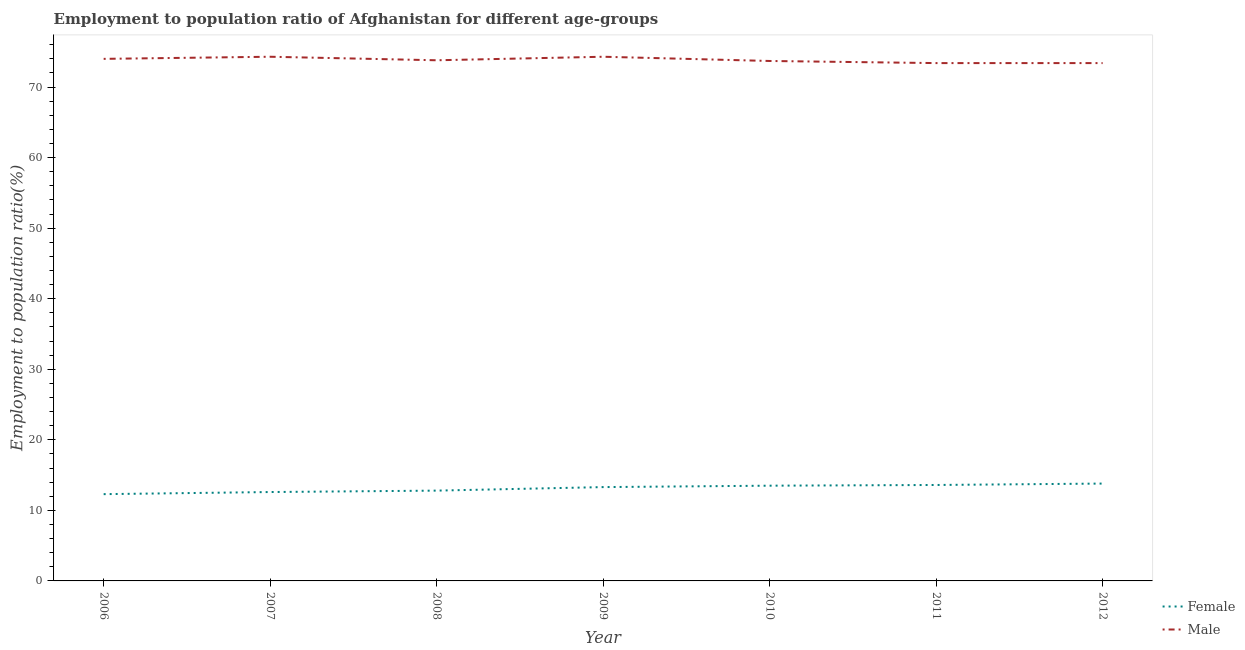How many different coloured lines are there?
Your answer should be very brief. 2. Does the line corresponding to employment to population ratio(female) intersect with the line corresponding to employment to population ratio(male)?
Provide a succinct answer. No. Is the number of lines equal to the number of legend labels?
Your answer should be very brief. Yes. What is the employment to population ratio(female) in 2012?
Offer a terse response. 13.8. Across all years, what is the maximum employment to population ratio(male)?
Ensure brevity in your answer.  74.3. Across all years, what is the minimum employment to population ratio(female)?
Provide a succinct answer. 12.3. In which year was the employment to population ratio(male) minimum?
Provide a short and direct response. 2011. What is the total employment to population ratio(female) in the graph?
Ensure brevity in your answer.  91.9. What is the difference between the employment to population ratio(male) in 2008 and that in 2009?
Your answer should be very brief. -0.5. What is the difference between the employment to population ratio(female) in 2012 and the employment to population ratio(male) in 2006?
Offer a terse response. -60.2. What is the average employment to population ratio(female) per year?
Provide a succinct answer. 13.13. In the year 2011, what is the difference between the employment to population ratio(male) and employment to population ratio(female)?
Your response must be concise. 59.8. What is the difference between the highest and the second highest employment to population ratio(male)?
Make the answer very short. 0. What is the difference between the highest and the lowest employment to population ratio(male)?
Your response must be concise. 0.9. In how many years, is the employment to population ratio(male) greater than the average employment to population ratio(male) taken over all years?
Your answer should be very brief. 3. Is the sum of the employment to population ratio(male) in 2007 and 2010 greater than the maximum employment to population ratio(female) across all years?
Your response must be concise. Yes. Is the employment to population ratio(male) strictly greater than the employment to population ratio(female) over the years?
Give a very brief answer. Yes. How many years are there in the graph?
Provide a short and direct response. 7. What is the difference between two consecutive major ticks on the Y-axis?
Offer a terse response. 10. Are the values on the major ticks of Y-axis written in scientific E-notation?
Provide a succinct answer. No. Does the graph contain grids?
Offer a very short reply. No. What is the title of the graph?
Your answer should be very brief. Employment to population ratio of Afghanistan for different age-groups. What is the label or title of the X-axis?
Make the answer very short. Year. What is the label or title of the Y-axis?
Your response must be concise. Employment to population ratio(%). What is the Employment to population ratio(%) in Female in 2006?
Your answer should be very brief. 12.3. What is the Employment to population ratio(%) in Male in 2006?
Offer a very short reply. 74. What is the Employment to population ratio(%) in Female in 2007?
Give a very brief answer. 12.6. What is the Employment to population ratio(%) of Male in 2007?
Your answer should be compact. 74.3. What is the Employment to population ratio(%) of Female in 2008?
Offer a terse response. 12.8. What is the Employment to population ratio(%) of Male in 2008?
Your answer should be compact. 73.8. What is the Employment to population ratio(%) in Female in 2009?
Ensure brevity in your answer.  13.3. What is the Employment to population ratio(%) of Male in 2009?
Give a very brief answer. 74.3. What is the Employment to population ratio(%) of Female in 2010?
Offer a terse response. 13.5. What is the Employment to population ratio(%) of Male in 2010?
Your answer should be compact. 73.7. What is the Employment to population ratio(%) of Female in 2011?
Keep it short and to the point. 13.6. What is the Employment to population ratio(%) in Male in 2011?
Provide a short and direct response. 73.4. What is the Employment to population ratio(%) in Female in 2012?
Provide a succinct answer. 13.8. What is the Employment to population ratio(%) in Male in 2012?
Offer a terse response. 73.4. Across all years, what is the maximum Employment to population ratio(%) of Female?
Ensure brevity in your answer.  13.8. Across all years, what is the maximum Employment to population ratio(%) in Male?
Your answer should be very brief. 74.3. Across all years, what is the minimum Employment to population ratio(%) of Female?
Make the answer very short. 12.3. Across all years, what is the minimum Employment to population ratio(%) in Male?
Your response must be concise. 73.4. What is the total Employment to population ratio(%) in Female in the graph?
Offer a very short reply. 91.9. What is the total Employment to population ratio(%) of Male in the graph?
Ensure brevity in your answer.  516.9. What is the difference between the Employment to population ratio(%) in Female in 2006 and that in 2007?
Provide a succinct answer. -0.3. What is the difference between the Employment to population ratio(%) of Male in 2006 and that in 2007?
Your answer should be compact. -0.3. What is the difference between the Employment to population ratio(%) in Male in 2006 and that in 2008?
Your answer should be very brief. 0.2. What is the difference between the Employment to population ratio(%) in Male in 2006 and that in 2009?
Make the answer very short. -0.3. What is the difference between the Employment to population ratio(%) of Male in 2006 and that in 2010?
Keep it short and to the point. 0.3. What is the difference between the Employment to population ratio(%) of Male in 2006 and that in 2012?
Ensure brevity in your answer.  0.6. What is the difference between the Employment to population ratio(%) of Female in 2007 and that in 2008?
Give a very brief answer. -0.2. What is the difference between the Employment to population ratio(%) in Male in 2007 and that in 2008?
Provide a short and direct response. 0.5. What is the difference between the Employment to population ratio(%) of Female in 2007 and that in 2009?
Provide a succinct answer. -0.7. What is the difference between the Employment to population ratio(%) of Male in 2007 and that in 2009?
Ensure brevity in your answer.  0. What is the difference between the Employment to population ratio(%) in Female in 2007 and that in 2011?
Your response must be concise. -1. What is the difference between the Employment to population ratio(%) in Male in 2007 and that in 2011?
Provide a succinct answer. 0.9. What is the difference between the Employment to population ratio(%) of Male in 2007 and that in 2012?
Your answer should be very brief. 0.9. What is the difference between the Employment to population ratio(%) in Male in 2008 and that in 2009?
Your answer should be very brief. -0.5. What is the difference between the Employment to population ratio(%) in Female in 2008 and that in 2010?
Provide a succinct answer. -0.7. What is the difference between the Employment to population ratio(%) in Male in 2008 and that in 2011?
Provide a short and direct response. 0.4. What is the difference between the Employment to population ratio(%) in Male in 2008 and that in 2012?
Your answer should be compact. 0.4. What is the difference between the Employment to population ratio(%) in Female in 2009 and that in 2010?
Give a very brief answer. -0.2. What is the difference between the Employment to population ratio(%) in Male in 2009 and that in 2010?
Your answer should be compact. 0.6. What is the difference between the Employment to population ratio(%) in Female in 2009 and that in 2011?
Give a very brief answer. -0.3. What is the difference between the Employment to population ratio(%) in Female in 2009 and that in 2012?
Provide a short and direct response. -0.5. What is the difference between the Employment to population ratio(%) in Male in 2011 and that in 2012?
Provide a short and direct response. 0. What is the difference between the Employment to population ratio(%) in Female in 2006 and the Employment to population ratio(%) in Male in 2007?
Keep it short and to the point. -62. What is the difference between the Employment to population ratio(%) in Female in 2006 and the Employment to population ratio(%) in Male in 2008?
Keep it short and to the point. -61.5. What is the difference between the Employment to population ratio(%) of Female in 2006 and the Employment to population ratio(%) of Male in 2009?
Make the answer very short. -62. What is the difference between the Employment to population ratio(%) in Female in 2006 and the Employment to population ratio(%) in Male in 2010?
Offer a very short reply. -61.4. What is the difference between the Employment to population ratio(%) of Female in 2006 and the Employment to population ratio(%) of Male in 2011?
Make the answer very short. -61.1. What is the difference between the Employment to population ratio(%) of Female in 2006 and the Employment to population ratio(%) of Male in 2012?
Offer a terse response. -61.1. What is the difference between the Employment to population ratio(%) of Female in 2007 and the Employment to population ratio(%) of Male in 2008?
Your response must be concise. -61.2. What is the difference between the Employment to population ratio(%) in Female in 2007 and the Employment to population ratio(%) in Male in 2009?
Provide a short and direct response. -61.7. What is the difference between the Employment to population ratio(%) of Female in 2007 and the Employment to population ratio(%) of Male in 2010?
Provide a succinct answer. -61.1. What is the difference between the Employment to population ratio(%) of Female in 2007 and the Employment to population ratio(%) of Male in 2011?
Your answer should be compact. -60.8. What is the difference between the Employment to population ratio(%) of Female in 2007 and the Employment to population ratio(%) of Male in 2012?
Offer a terse response. -60.8. What is the difference between the Employment to population ratio(%) of Female in 2008 and the Employment to population ratio(%) of Male in 2009?
Your answer should be compact. -61.5. What is the difference between the Employment to population ratio(%) in Female in 2008 and the Employment to population ratio(%) in Male in 2010?
Keep it short and to the point. -60.9. What is the difference between the Employment to population ratio(%) in Female in 2008 and the Employment to population ratio(%) in Male in 2011?
Offer a very short reply. -60.6. What is the difference between the Employment to population ratio(%) of Female in 2008 and the Employment to population ratio(%) of Male in 2012?
Provide a succinct answer. -60.6. What is the difference between the Employment to population ratio(%) of Female in 2009 and the Employment to population ratio(%) of Male in 2010?
Keep it short and to the point. -60.4. What is the difference between the Employment to population ratio(%) of Female in 2009 and the Employment to population ratio(%) of Male in 2011?
Your answer should be compact. -60.1. What is the difference between the Employment to population ratio(%) in Female in 2009 and the Employment to population ratio(%) in Male in 2012?
Offer a terse response. -60.1. What is the difference between the Employment to population ratio(%) of Female in 2010 and the Employment to population ratio(%) of Male in 2011?
Your answer should be compact. -59.9. What is the difference between the Employment to population ratio(%) in Female in 2010 and the Employment to population ratio(%) in Male in 2012?
Provide a succinct answer. -59.9. What is the difference between the Employment to population ratio(%) in Female in 2011 and the Employment to population ratio(%) in Male in 2012?
Keep it short and to the point. -59.8. What is the average Employment to population ratio(%) of Female per year?
Keep it short and to the point. 13.13. What is the average Employment to population ratio(%) in Male per year?
Provide a short and direct response. 73.84. In the year 2006, what is the difference between the Employment to population ratio(%) in Female and Employment to population ratio(%) in Male?
Your answer should be compact. -61.7. In the year 2007, what is the difference between the Employment to population ratio(%) in Female and Employment to population ratio(%) in Male?
Offer a very short reply. -61.7. In the year 2008, what is the difference between the Employment to population ratio(%) of Female and Employment to population ratio(%) of Male?
Offer a very short reply. -61. In the year 2009, what is the difference between the Employment to population ratio(%) of Female and Employment to population ratio(%) of Male?
Keep it short and to the point. -61. In the year 2010, what is the difference between the Employment to population ratio(%) in Female and Employment to population ratio(%) in Male?
Give a very brief answer. -60.2. In the year 2011, what is the difference between the Employment to population ratio(%) in Female and Employment to population ratio(%) in Male?
Provide a succinct answer. -59.8. In the year 2012, what is the difference between the Employment to population ratio(%) of Female and Employment to population ratio(%) of Male?
Keep it short and to the point. -59.6. What is the ratio of the Employment to population ratio(%) in Female in 2006 to that in 2007?
Your answer should be compact. 0.98. What is the ratio of the Employment to population ratio(%) in Female in 2006 to that in 2008?
Ensure brevity in your answer.  0.96. What is the ratio of the Employment to population ratio(%) of Male in 2006 to that in 2008?
Provide a short and direct response. 1. What is the ratio of the Employment to population ratio(%) in Female in 2006 to that in 2009?
Make the answer very short. 0.92. What is the ratio of the Employment to population ratio(%) in Female in 2006 to that in 2010?
Offer a very short reply. 0.91. What is the ratio of the Employment to population ratio(%) of Female in 2006 to that in 2011?
Ensure brevity in your answer.  0.9. What is the ratio of the Employment to population ratio(%) in Male in 2006 to that in 2011?
Your response must be concise. 1.01. What is the ratio of the Employment to population ratio(%) in Female in 2006 to that in 2012?
Make the answer very short. 0.89. What is the ratio of the Employment to population ratio(%) of Male in 2006 to that in 2012?
Your response must be concise. 1.01. What is the ratio of the Employment to population ratio(%) of Female in 2007 to that in 2008?
Your answer should be compact. 0.98. What is the ratio of the Employment to population ratio(%) of Male in 2007 to that in 2008?
Your answer should be very brief. 1.01. What is the ratio of the Employment to population ratio(%) in Female in 2007 to that in 2010?
Give a very brief answer. 0.93. What is the ratio of the Employment to population ratio(%) of Male in 2007 to that in 2010?
Your answer should be compact. 1.01. What is the ratio of the Employment to population ratio(%) of Female in 2007 to that in 2011?
Keep it short and to the point. 0.93. What is the ratio of the Employment to population ratio(%) in Male in 2007 to that in 2011?
Ensure brevity in your answer.  1.01. What is the ratio of the Employment to population ratio(%) in Female in 2007 to that in 2012?
Make the answer very short. 0.91. What is the ratio of the Employment to population ratio(%) of Male in 2007 to that in 2012?
Keep it short and to the point. 1.01. What is the ratio of the Employment to population ratio(%) of Female in 2008 to that in 2009?
Ensure brevity in your answer.  0.96. What is the ratio of the Employment to population ratio(%) in Female in 2008 to that in 2010?
Provide a short and direct response. 0.95. What is the ratio of the Employment to population ratio(%) in Male in 2008 to that in 2010?
Your response must be concise. 1. What is the ratio of the Employment to population ratio(%) in Male in 2008 to that in 2011?
Your answer should be compact. 1.01. What is the ratio of the Employment to population ratio(%) in Female in 2008 to that in 2012?
Provide a short and direct response. 0.93. What is the ratio of the Employment to population ratio(%) of Male in 2008 to that in 2012?
Provide a succinct answer. 1.01. What is the ratio of the Employment to population ratio(%) in Female in 2009 to that in 2010?
Provide a succinct answer. 0.99. What is the ratio of the Employment to population ratio(%) in Male in 2009 to that in 2010?
Offer a terse response. 1.01. What is the ratio of the Employment to population ratio(%) in Female in 2009 to that in 2011?
Keep it short and to the point. 0.98. What is the ratio of the Employment to population ratio(%) in Male in 2009 to that in 2011?
Offer a terse response. 1.01. What is the ratio of the Employment to population ratio(%) of Female in 2009 to that in 2012?
Your answer should be very brief. 0.96. What is the ratio of the Employment to population ratio(%) in Male in 2009 to that in 2012?
Offer a very short reply. 1.01. What is the ratio of the Employment to population ratio(%) in Female in 2010 to that in 2011?
Provide a succinct answer. 0.99. What is the ratio of the Employment to population ratio(%) in Female in 2010 to that in 2012?
Give a very brief answer. 0.98. What is the ratio of the Employment to population ratio(%) of Male in 2010 to that in 2012?
Provide a succinct answer. 1. What is the ratio of the Employment to population ratio(%) of Female in 2011 to that in 2012?
Provide a short and direct response. 0.99. What is the ratio of the Employment to population ratio(%) of Male in 2011 to that in 2012?
Keep it short and to the point. 1. What is the difference between the highest and the second highest Employment to population ratio(%) of Female?
Keep it short and to the point. 0.2. What is the difference between the highest and the second highest Employment to population ratio(%) in Male?
Your response must be concise. 0. 